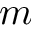Convert formula to latex. <formula><loc_0><loc_0><loc_500><loc_500>m</formula> 